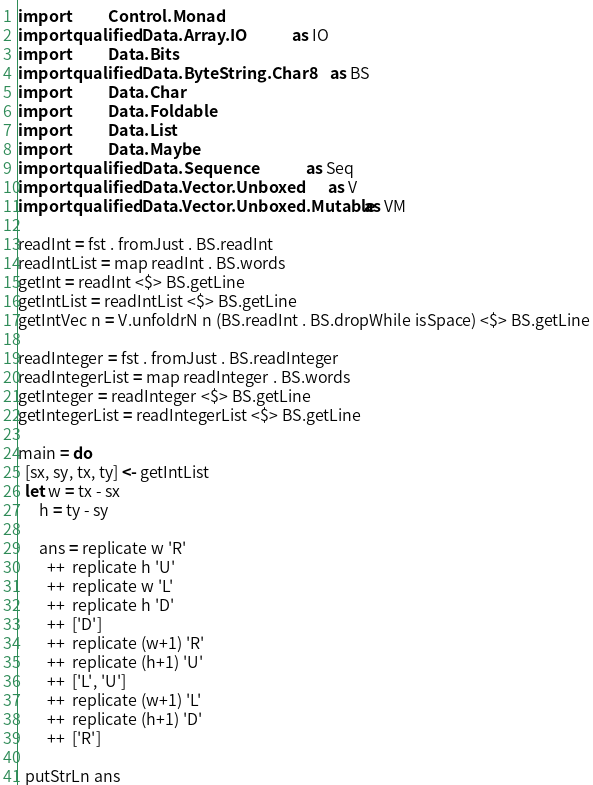Convert code to text. <code><loc_0><loc_0><loc_500><loc_500><_Haskell_>import           Control.Monad
import qualified Data.Array.IO               as IO
import           Data.Bits
import qualified Data.ByteString.Char8       as BS
import           Data.Char
import           Data.Foldable
import           Data.List
import           Data.Maybe
import qualified Data.Sequence               as Seq
import qualified Data.Vector.Unboxed         as V
import qualified Data.Vector.Unboxed.Mutable as VM

readInt = fst . fromJust . BS.readInt
readIntList = map readInt . BS.words
getInt = readInt <$> BS.getLine
getIntList = readIntList <$> BS.getLine
getIntVec n = V.unfoldrN n (BS.readInt . BS.dropWhile isSpace) <$> BS.getLine

readInteger = fst . fromJust . BS.readInteger
readIntegerList = map readInteger . BS.words
getInteger = readInteger <$> BS.getLine
getIntegerList = readIntegerList <$> BS.getLine

main = do
  [sx, sy, tx, ty] <- getIntList
  let w = tx - sx
      h = ty - sy

      ans = replicate w 'R'
        ++  replicate h 'U'
        ++  replicate w 'L'
        ++  replicate h 'D'
        ++  ['D']
        ++  replicate (w+1) 'R'
        ++  replicate (h+1) 'U'
        ++  ['L', 'U']
        ++  replicate (w+1) 'L'
        ++  replicate (h+1) 'D'
        ++  ['R']

  putStrLn ans</code> 